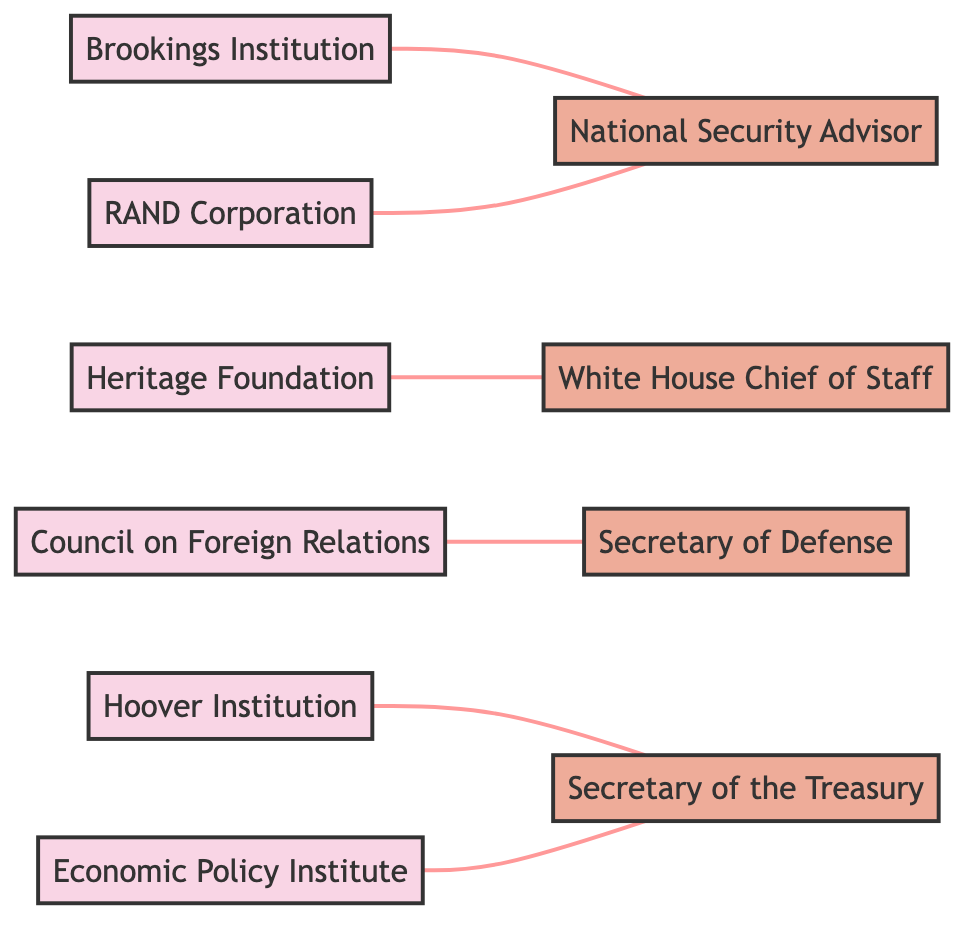What is the total number of think tanks represented in the diagram? The diagram lists 6 distinct think tanks: Brookings Institution, Heritage Foundation, Council on Foreign Relations, Hoover Institution, RAND Corporation, and Economic Policy Institute. Thus, the total number is 6.
Answer: 6 Which government policy advisor is connected to the Brookings Institution? The edge from Brookings Institution leads to National Security Advisor, indicating a direct connection.
Answer: National Security Advisor How many edges are there in the graph? Counting the connections (edges) between the nodes, there are 6 connections: Brookings Institution to National Security Advisor, Heritage Foundation to White House Chief of Staff, Council on Foreign Relations to Secretary of Defense, Hoover Institution to Secretary of the Treasury, RAND Corporation to National Security Advisor, and Economic Policy Institute to Secretary of the Treasury. The total is 6 edges.
Answer: 6 Which think tank has a connection with both the National Security Advisor and the Secretary of the Treasury? The RAND Corporation connects to National Security Advisor, and the Economic Policy Institute connects to Secretary of the Treasury, but no single think tank connects to both. Thus, the answer is none.
Answer: None What is the relationship type between Heritage Foundation and its connected government policy advisor? The connection between Heritage Foundation and White House Chief of Staff is established through an edge, which denotes a direct relationship.
Answer: Edge Which government policy advisor is linked to more than one think tank? The Secretary of the Treasury is connected to both Hoover Institution and Economic Policy Institute, indicating that it is linked to multiple think tanks.
Answer: Secretary of the Treasury Which think tank is connected to the Secretary of Defense? The diagram shows an edge connecting Council on Foreign Relations to Secretary of Defense, indicating this direct relationship.
Answer: Council on Foreign Relations Is there any think tank that is connected to both the National Security Advisor and the Secretary of Defense? The National Security Advisor is connected to Brookings Institution and RAND Corporation, while Secretary of Defense is connected to Council on Foreign Relations. However, no think tank connects to both advisors.
Answer: None 